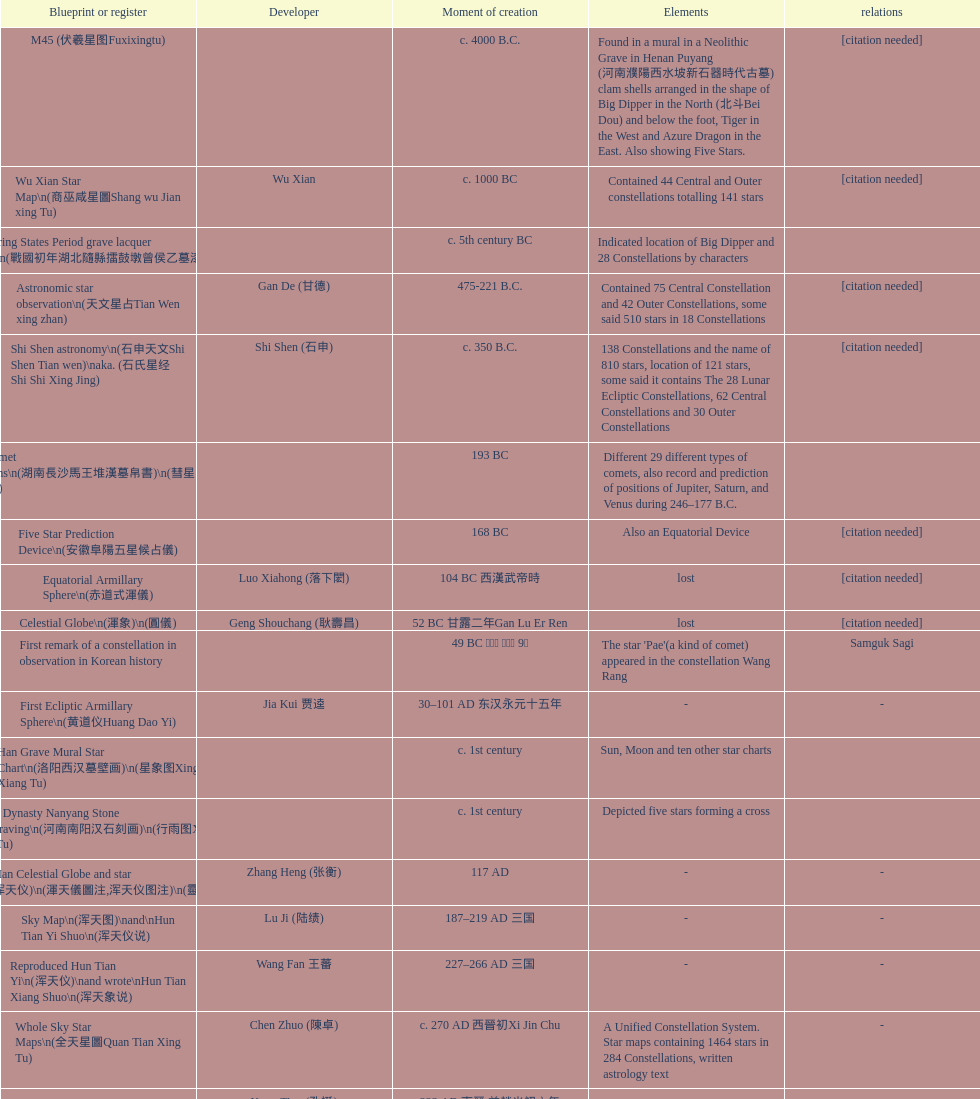Did xu guang ci or su song create the five star charts in 1094 ad? Su Song 蘇頌. 